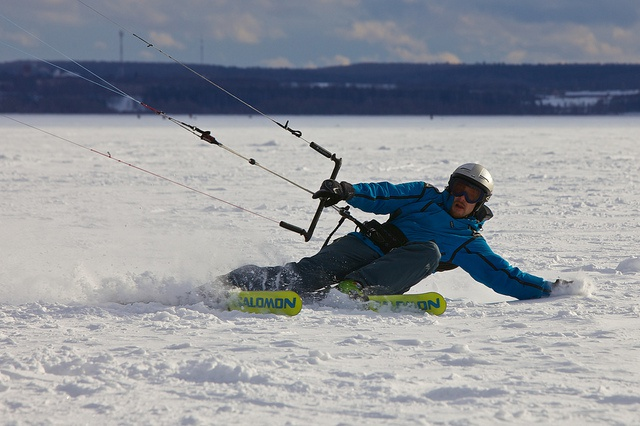Describe the objects in this image and their specific colors. I can see people in gray, black, navy, and lightgray tones and skis in gray, olive, and darkgray tones in this image. 